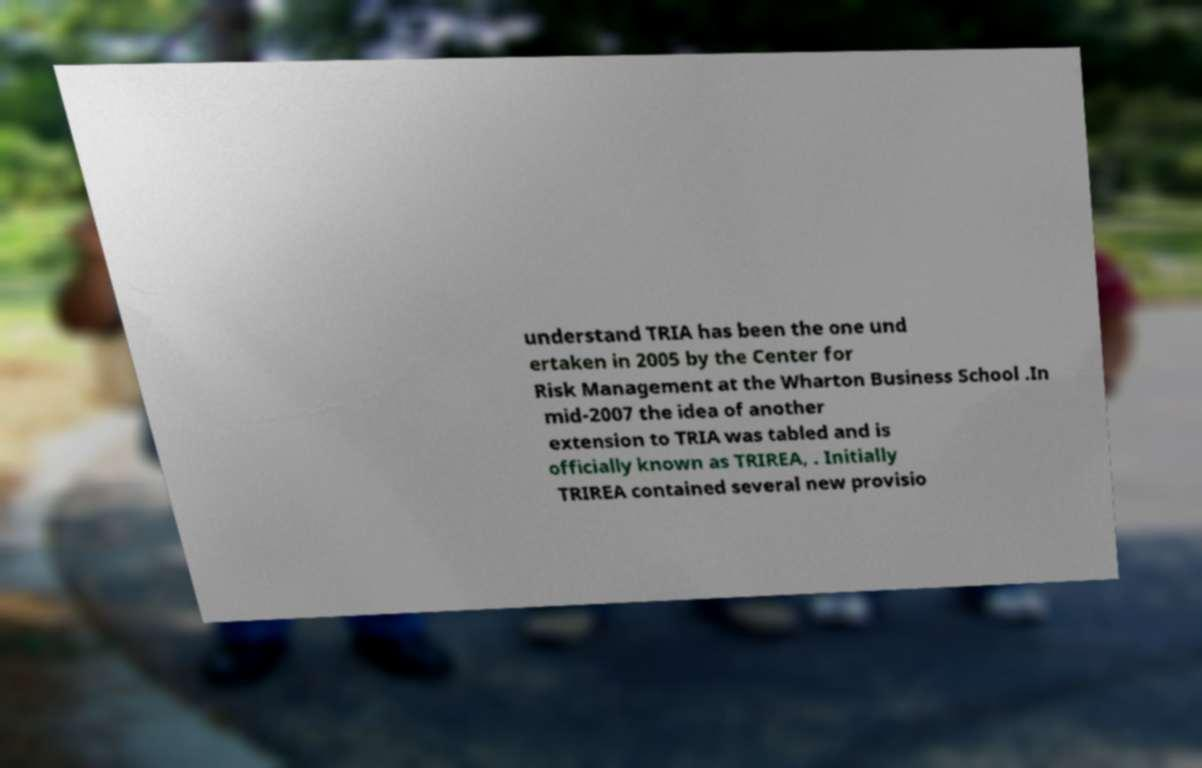Please identify and transcribe the text found in this image. understand TRIA has been the one und ertaken in 2005 by the Center for Risk Management at the Wharton Business School .In mid-2007 the idea of another extension to TRIA was tabled and is officially known as TRIREA, . Initially TRIREA contained several new provisio 